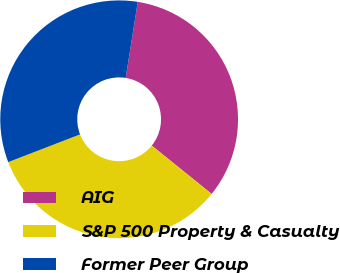Convert chart. <chart><loc_0><loc_0><loc_500><loc_500><pie_chart><fcel>AIG<fcel>S&P 500 Property & Casualty<fcel>Former Peer Group<nl><fcel>33.3%<fcel>33.33%<fcel>33.37%<nl></chart> 